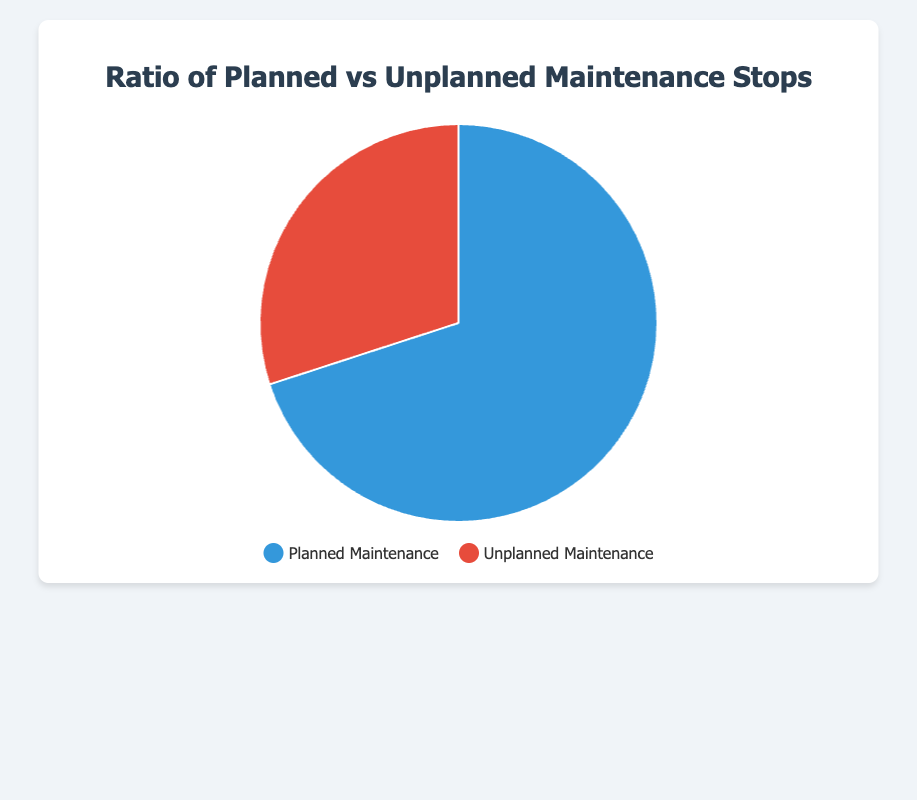What types of maintenance stops are shown in the pie chart? The pie chart is divided into two sections, one for "Planned Maintenance" and one for "Unplanned Maintenance."
Answer: Planned Maintenance and Unplanned Maintenance What is the ratio of planned maintenance stops? The pie chart indicates that the segment representing "Planned Maintenance" covers 70% of the chart.
Answer: 70% How much greater is the percentage of planned maintenance than unplanned maintenance? The pie chart shows that planned maintenance is 70% and unplanned maintenance is 30%. The difference is 70% - 30%.
Answer: 40% What color represents planned maintenance in the chart? The legend indicates that "Planned Maintenance" is represented by the blue segment in the pie chart.
Answer: Blue If there were a total of 100 maintenance stops, how many of these would be unplanned? According to the pie chart, unplanned maintenance makes up 30%. Therefore, 30% of 100 maintenance stops would be unplanned.
Answer: 30 If the number of planned maintenance stops is 70, how many unplanned stops are there? Given that the ratio of unplanned stops is 30%, use the number of planned stops (70) to find the total (100). Then, calculate 30% of 100.
Answer: 30 Which maintenance type occurs more frequently? The pie chart shows that "Planned Maintenance" occupies a larger portion (70%) compared to "Unplanned Maintenance" (30%).
Answer: Planned Maintenance What is the difference in the number of planned and unplanned maintenance stops if there are 100 in total? The pie chart indicates that 70% are planned and 30% are unplanned. Given 100 total stops, planned stops are 70 and unplanned stops are 30. The difference is 70 - 30.
Answer: 40 What is the significance of the colors used in the pie chart? The legend next to the pie chart uses blue to signify "Planned Maintenance" and red to signify "Unplanned Maintenance." This helps in distinguishing the two types of stops visually.
Answer: Blue for Planned Maintenance, Red for Unplanned Maintenance If the total number of maintenance stops is doubled, keeping the same ratio, what would be the new counts for planned and unplanned stops? The original ratio is 70% planned and 30% unplanned. Doubling the total from 100 to 200 stops, we calculate: Planned: 70%*200 = 140, Unplanned: 30%*200 = 60.
Answer: 140 planned, 60 unplanned 